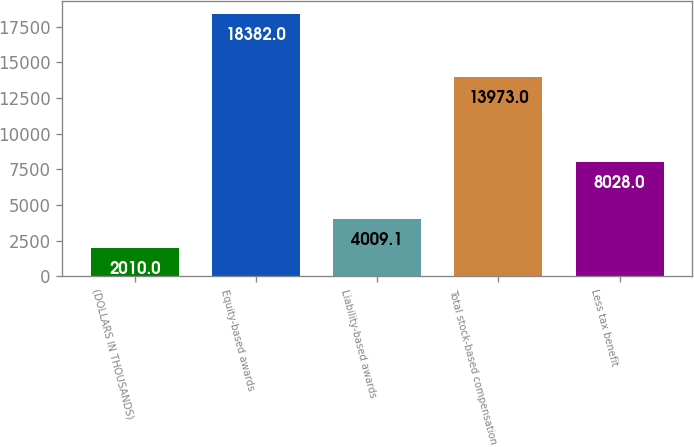Convert chart. <chart><loc_0><loc_0><loc_500><loc_500><bar_chart><fcel>(DOLLARS IN THOUSANDS)<fcel>Equity-based awards<fcel>Liability-based awards<fcel>Total stock-based compensation<fcel>Less tax benefit<nl><fcel>2010<fcel>18382<fcel>4009.1<fcel>13973<fcel>8028<nl></chart> 